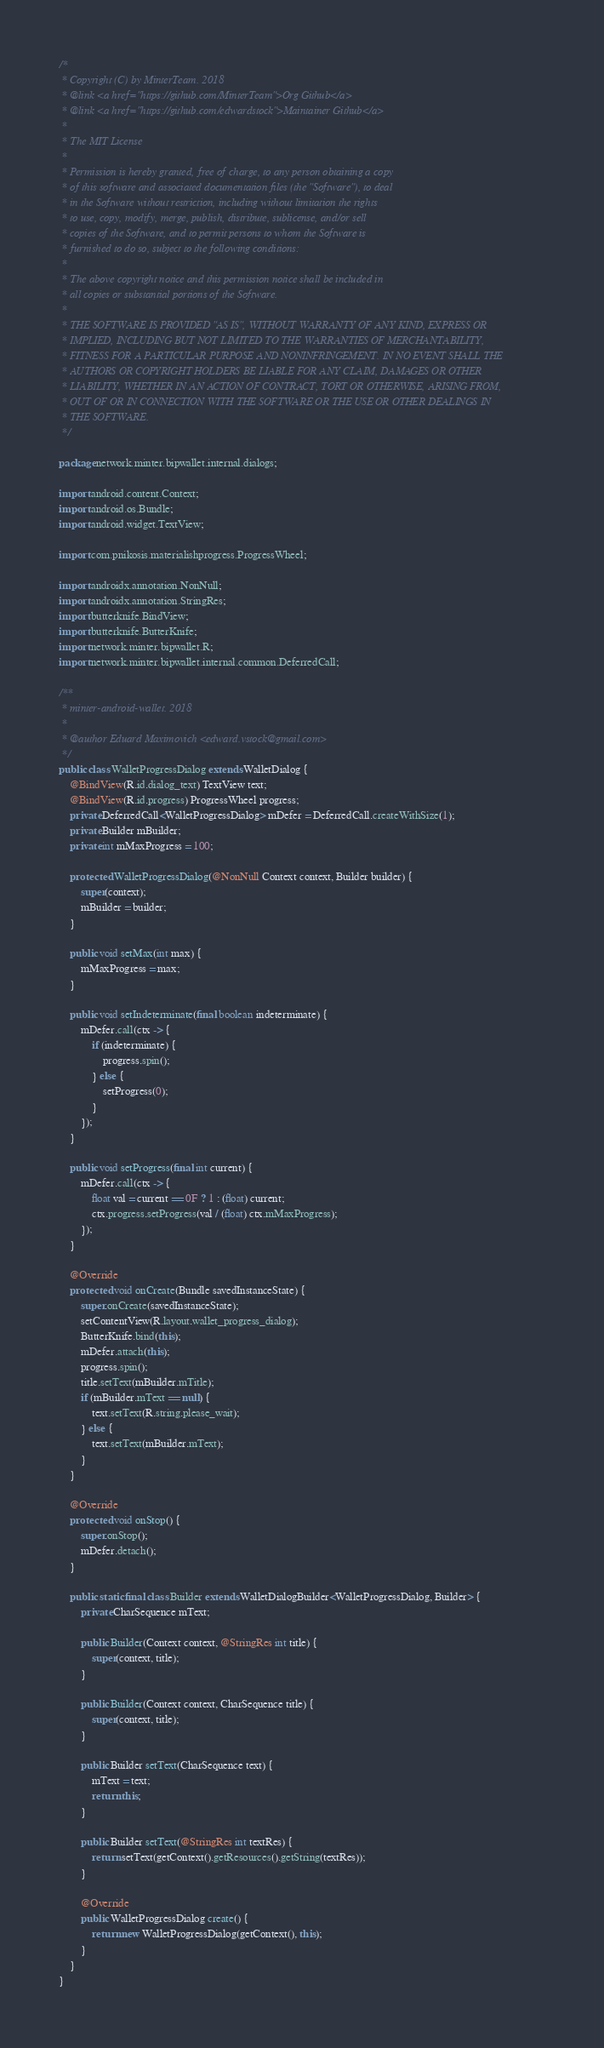Convert code to text. <code><loc_0><loc_0><loc_500><loc_500><_Java_>/*
 * Copyright (C) by MinterTeam. 2018
 * @link <a href="https://github.com/MinterTeam">Org Github</a>
 * @link <a href="https://github.com/edwardstock">Maintainer Github</a>
 *
 * The MIT License
 *
 * Permission is hereby granted, free of charge, to any person obtaining a copy
 * of this software and associated documentation files (the "Software"), to deal
 * in the Software without restriction, including without limitation the rights
 * to use, copy, modify, merge, publish, distribute, sublicense, and/or sell
 * copies of the Software, and to permit persons to whom the Software is
 * furnished to do so, subject to the following conditions:
 *
 * The above copyright notice and this permission notice shall be included in
 * all copies or substantial portions of the Software.
 *
 * THE SOFTWARE IS PROVIDED "AS IS", WITHOUT WARRANTY OF ANY KIND, EXPRESS OR
 * IMPLIED, INCLUDING BUT NOT LIMITED TO THE WARRANTIES OF MERCHANTABILITY,
 * FITNESS FOR A PARTICULAR PURPOSE AND NONINFRINGEMENT. IN NO EVENT SHALL THE
 * AUTHORS OR COPYRIGHT HOLDERS BE LIABLE FOR ANY CLAIM, DAMAGES OR OTHER
 * LIABILITY, WHETHER IN AN ACTION OF CONTRACT, TORT OR OTHERWISE, ARISING FROM,
 * OUT OF OR IN CONNECTION WITH THE SOFTWARE OR THE USE OR OTHER DEALINGS IN
 * THE SOFTWARE.
 */

package network.minter.bipwallet.internal.dialogs;

import android.content.Context;
import android.os.Bundle;
import android.widget.TextView;

import com.pnikosis.materialishprogress.ProgressWheel;

import androidx.annotation.NonNull;
import androidx.annotation.StringRes;
import butterknife.BindView;
import butterknife.ButterKnife;
import network.minter.bipwallet.R;
import network.minter.bipwallet.internal.common.DeferredCall;

/**
 * minter-android-wallet. 2018
 *
 * @author Eduard Maximovich <edward.vstock@gmail.com>
 */
public class WalletProgressDialog extends WalletDialog {
    @BindView(R.id.dialog_text) TextView text;
    @BindView(R.id.progress) ProgressWheel progress;
    private DeferredCall<WalletProgressDialog> mDefer = DeferredCall.createWithSize(1);
    private Builder mBuilder;
    private int mMaxProgress = 100;

    protected WalletProgressDialog(@NonNull Context context, Builder builder) {
        super(context);
        mBuilder = builder;
    }

    public void setMax(int max) {
        mMaxProgress = max;
    }

    public void setIndeterminate(final boolean indeterminate) {
        mDefer.call(ctx -> {
            if (indeterminate) {
                progress.spin();
            } else {
                setProgress(0);
            }
        });
    }

    public void setProgress(final int current) {
        mDefer.call(ctx -> {
            float val = current == 0F ? 1 : (float) current;
            ctx.progress.setProgress(val / (float) ctx.mMaxProgress);
        });
    }

    @Override
    protected void onCreate(Bundle savedInstanceState) {
        super.onCreate(savedInstanceState);
        setContentView(R.layout.wallet_progress_dialog);
        ButterKnife.bind(this);
        mDefer.attach(this);
        progress.spin();
        title.setText(mBuilder.mTitle);
        if (mBuilder.mText == null) {
            text.setText(R.string.please_wait);
        } else {
            text.setText(mBuilder.mText);
        }
    }

    @Override
    protected void onStop() {
        super.onStop();
        mDefer.detach();
    }

    public static final class Builder extends WalletDialogBuilder<WalletProgressDialog, Builder> {
        private CharSequence mText;

        public Builder(Context context, @StringRes int title) {
            super(context, title);
        }

        public Builder(Context context, CharSequence title) {
            super(context, title);
        }

        public Builder setText(CharSequence text) {
            mText = text;
            return this;
        }

        public Builder setText(@StringRes int textRes) {
            return setText(getContext().getResources().getString(textRes));
        }

        @Override
        public WalletProgressDialog create() {
            return new WalletProgressDialog(getContext(), this);
        }
    }
}
</code> 